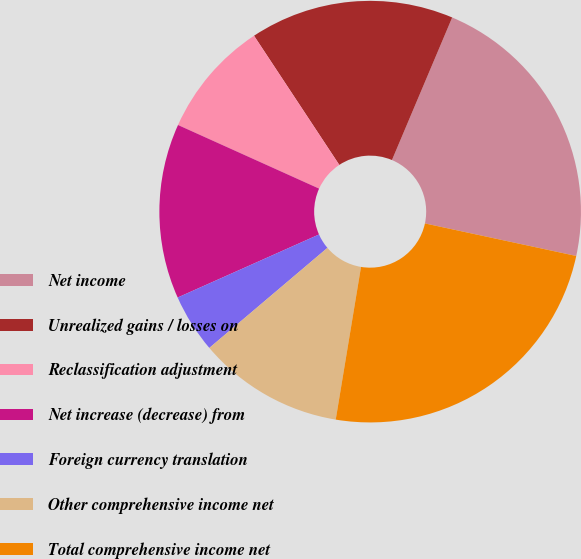Convert chart. <chart><loc_0><loc_0><loc_500><loc_500><pie_chart><fcel>Net income<fcel>Unrealized gains / losses on<fcel>Reclassification adjustment<fcel>Net increase (decrease) from<fcel>Foreign currency translation<fcel>Other comprehensive income net<fcel>Total comprehensive income net<nl><fcel>22.01%<fcel>15.65%<fcel>8.97%<fcel>13.42%<fcel>4.51%<fcel>11.2%<fcel>24.24%<nl></chart> 